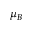<formula> <loc_0><loc_0><loc_500><loc_500>\mu _ { B }</formula> 